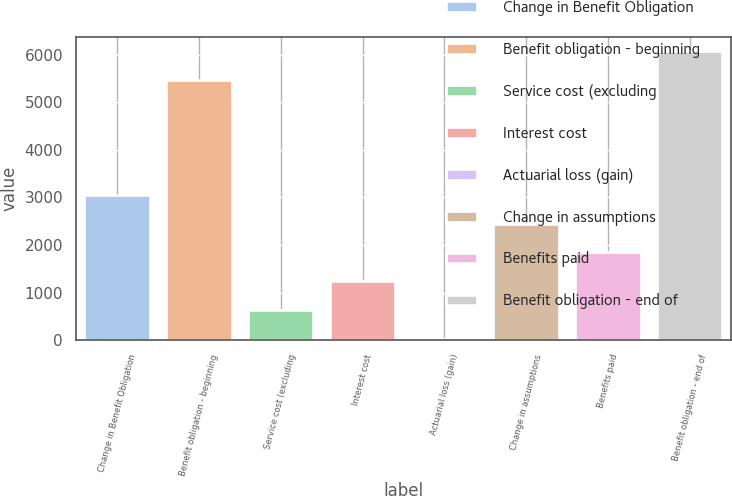Convert chart to OTSL. <chart><loc_0><loc_0><loc_500><loc_500><bar_chart><fcel>Change in Benefit Obligation<fcel>Benefit obligation - beginning<fcel>Service cost (excluding<fcel>Interest cost<fcel>Actuarial loss (gain)<fcel>Change in assumptions<fcel>Benefits paid<fcel>Benefit obligation - end of<nl><fcel>3054<fcel>5465<fcel>633.2<fcel>1238.4<fcel>28<fcel>2448.8<fcel>1843.6<fcel>6080<nl></chart> 